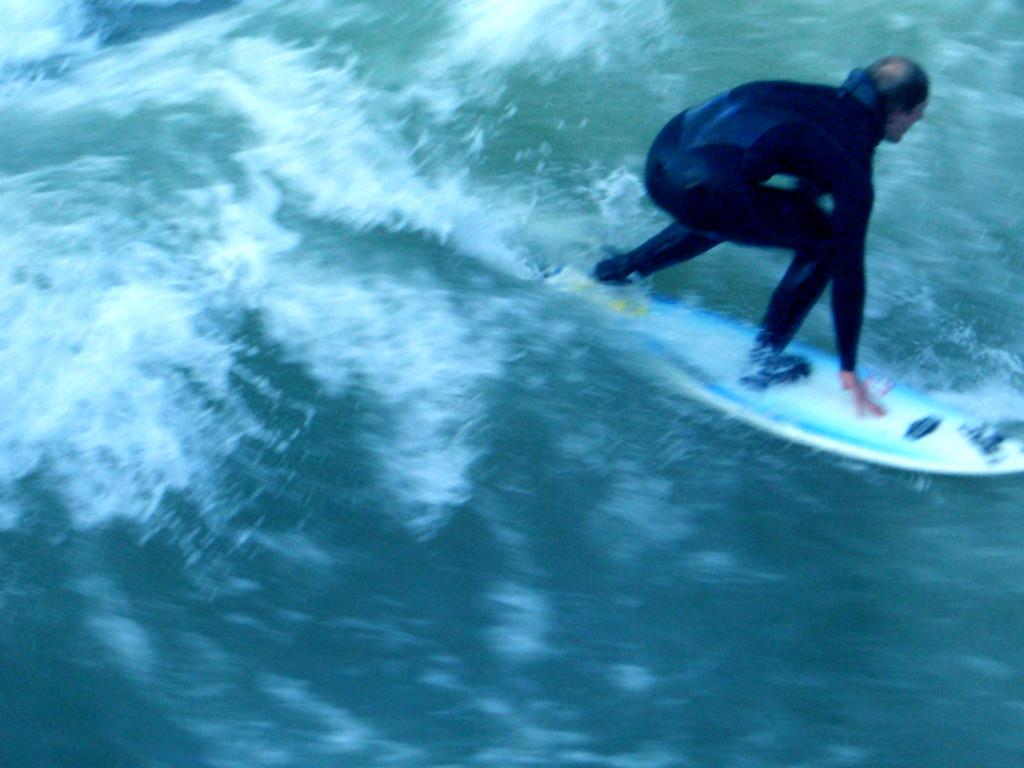What is the person in the image doing? The person is surfing on the water. What tool or equipment is the person using to surf? The person is using a surfboard. What type of ticket does the person have to surf in the image? There is no mention of a ticket in the image; the person is simply surfing on the water using a surfboard. Can you see any credit cards in the image? There is no mention of credit cards in the image; the focus is on the person surfing on the water using a surfboard. 